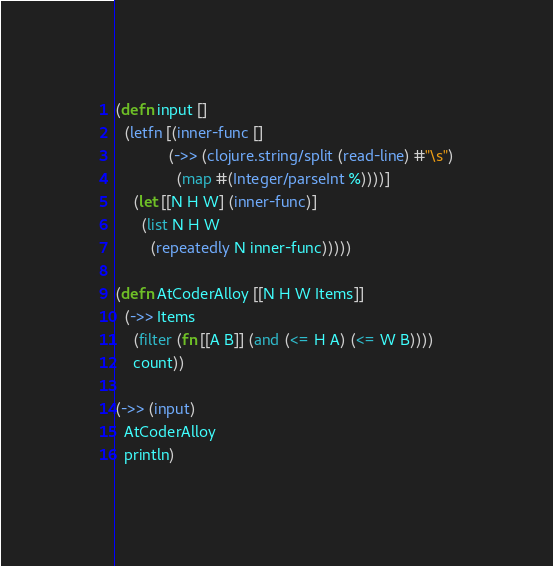<code> <loc_0><loc_0><loc_500><loc_500><_Clojure_>(defn input []
  (letfn [(inner-func []
            (->> (clojure.string/split (read-line) #"\s")
              (map #(Integer/parseInt %))))]
    (let [[N H W] (inner-func)]
      (list N H W
        (repeatedly N inner-func)))))

(defn AtCoderAlloy [[N H W Items]]
  (->> Items
    (filter (fn [[A B]] (and (<= H A) (<= W B))))
    count))

(->> (input)
  AtCoderAlloy
  println)</code> 